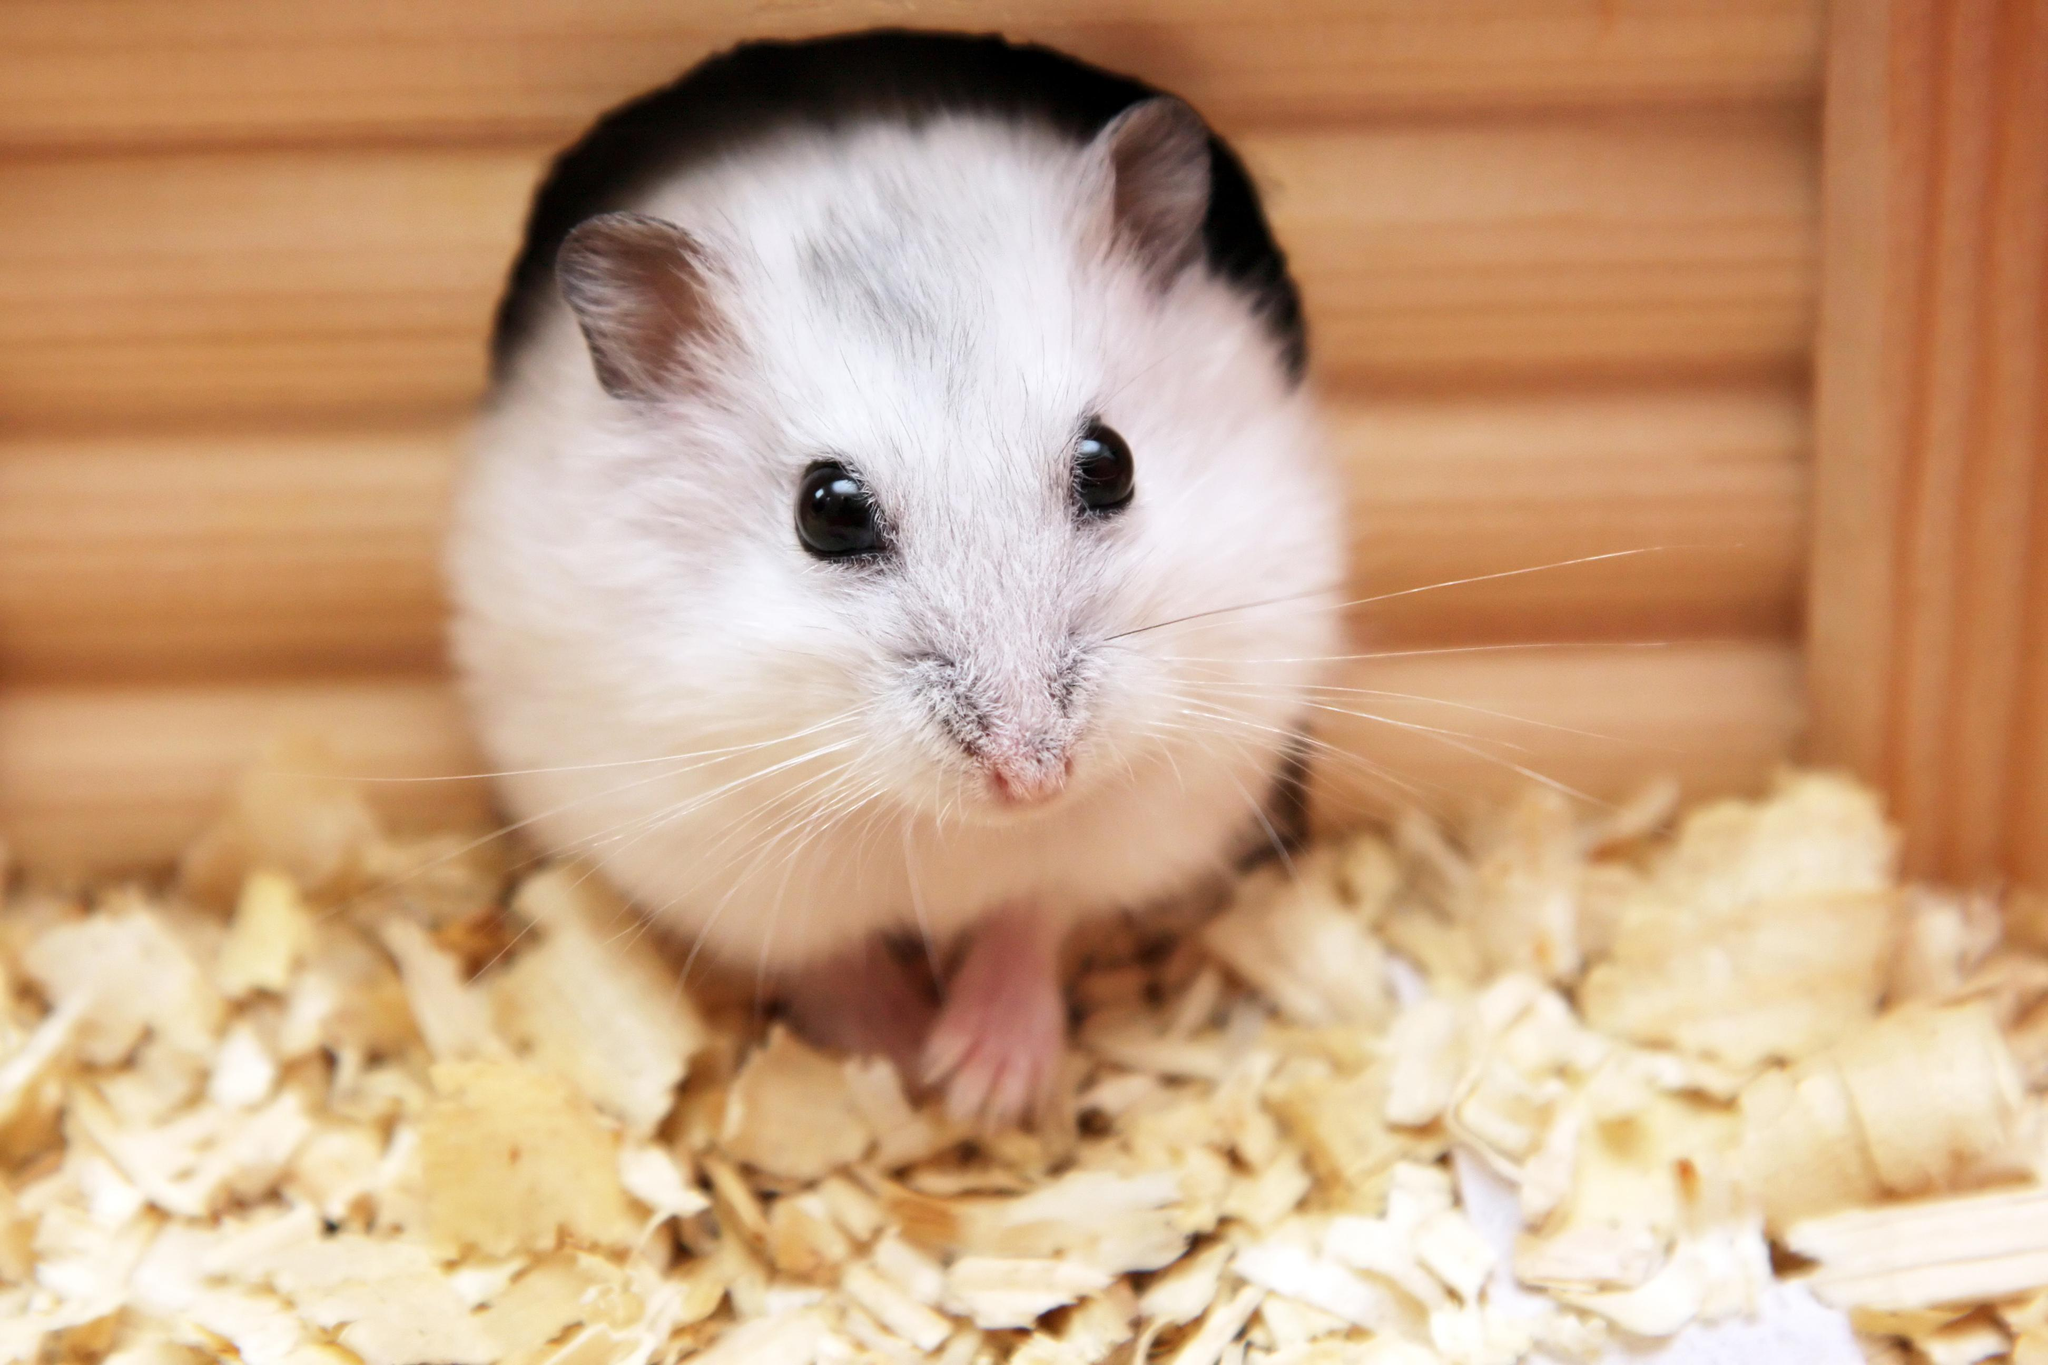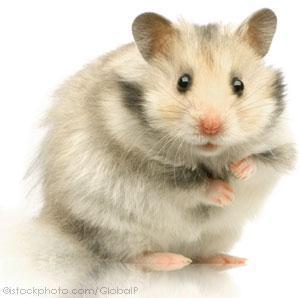The first image is the image on the left, the second image is the image on the right. Analyze the images presented: Is the assertion "A single rodent is lying down on a smooth surface in the image on the right." valid? Answer yes or no. No. The first image is the image on the left, the second image is the image on the right. For the images displayed, is the sentence "Each image contains a single hamster, and at least one hamster is standing upright with its front paws in front of its body." factually correct? Answer yes or no. Yes. 